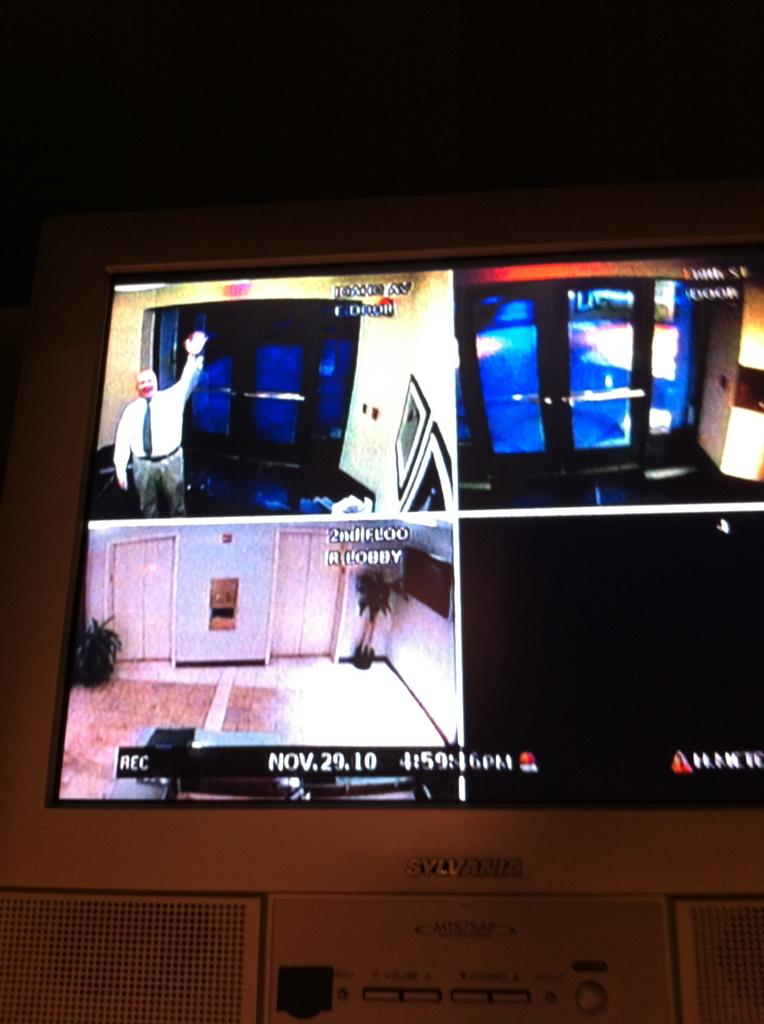<image>
Write a terse but informative summary of the picture. the date is Nov 29 and it is a large screen 